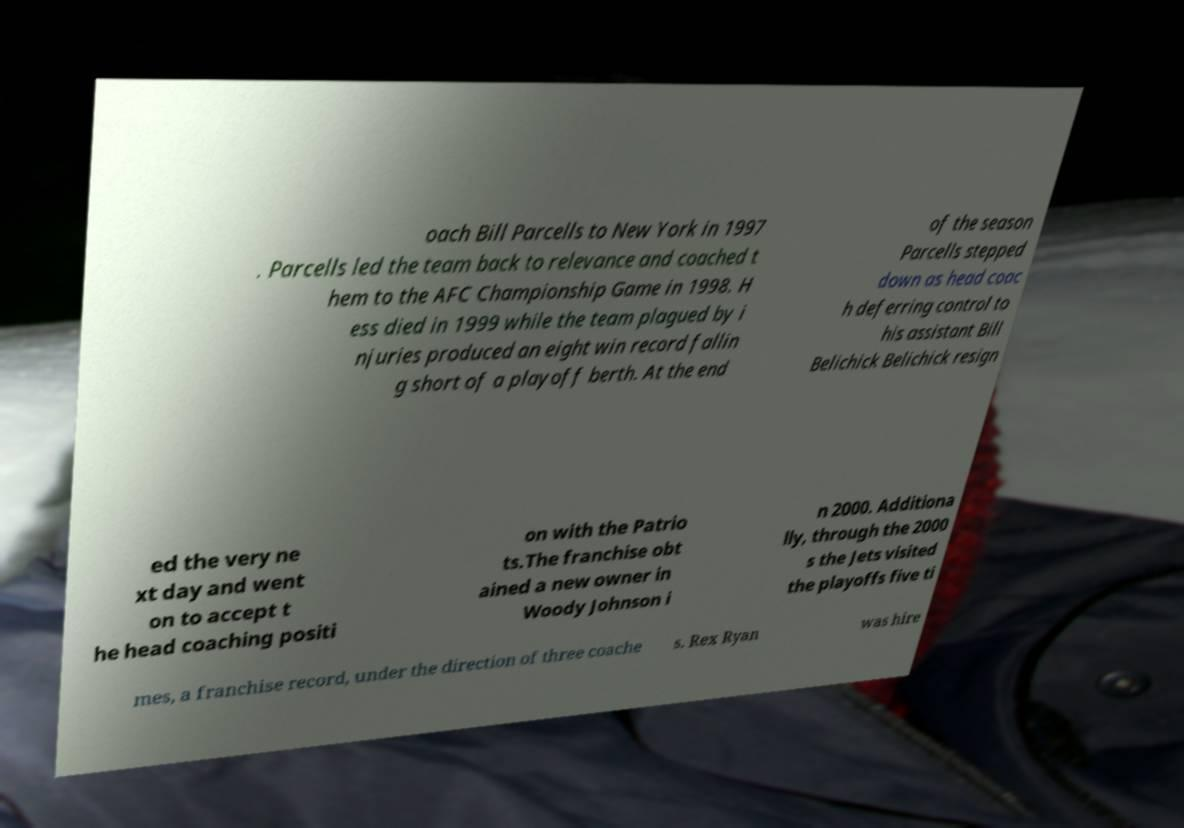There's text embedded in this image that I need extracted. Can you transcribe it verbatim? oach Bill Parcells to New York in 1997 . Parcells led the team back to relevance and coached t hem to the AFC Championship Game in 1998. H ess died in 1999 while the team plagued by i njuries produced an eight win record fallin g short of a playoff berth. At the end of the season Parcells stepped down as head coac h deferring control to his assistant Bill Belichick Belichick resign ed the very ne xt day and went on to accept t he head coaching positi on with the Patrio ts.The franchise obt ained a new owner in Woody Johnson i n 2000. Additiona lly, through the 2000 s the Jets visited the playoffs five ti mes, a franchise record, under the direction of three coache s. Rex Ryan was hire 